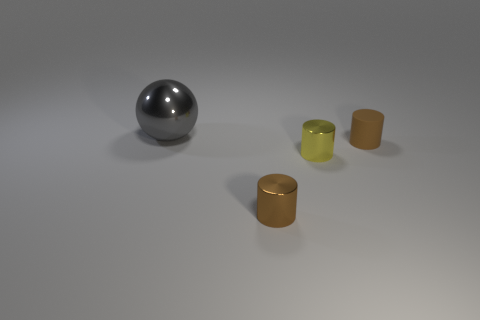Subtract all rubber cylinders. How many cylinders are left? 2 Add 2 brown cylinders. How many objects exist? 6 Subtract all yellow cylinders. How many cylinders are left? 2 Subtract 1 cylinders. How many cylinders are left? 2 Subtract 1 yellow cylinders. How many objects are left? 3 Subtract all cylinders. How many objects are left? 1 Subtract all purple balls. Subtract all gray cubes. How many balls are left? 1 Subtract all red cubes. How many cyan cylinders are left? 0 Subtract all small metal balls. Subtract all tiny shiny things. How many objects are left? 2 Add 4 brown rubber objects. How many brown rubber objects are left? 5 